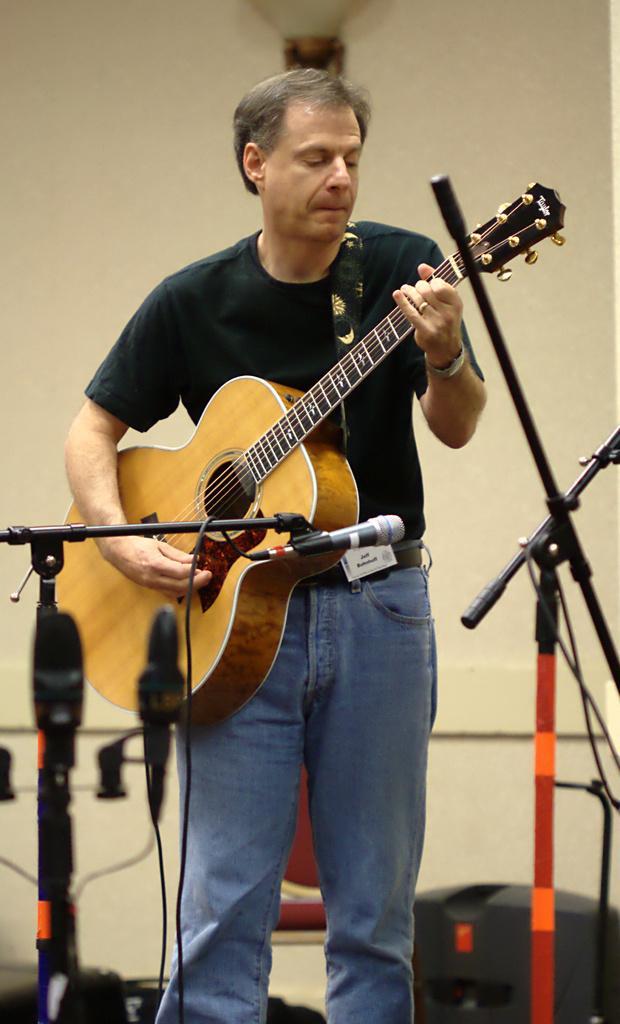Please provide a concise description of this image. This is the picture of a person who wore a black shirt and blue jeans who is holding a guitar and playing it in front of a mike. 